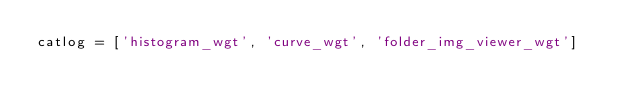Convert code to text. <code><loc_0><loc_0><loc_500><loc_500><_Python_>catlog = ['histogram_wgt', 'curve_wgt', 'folder_img_viewer_wgt']</code> 